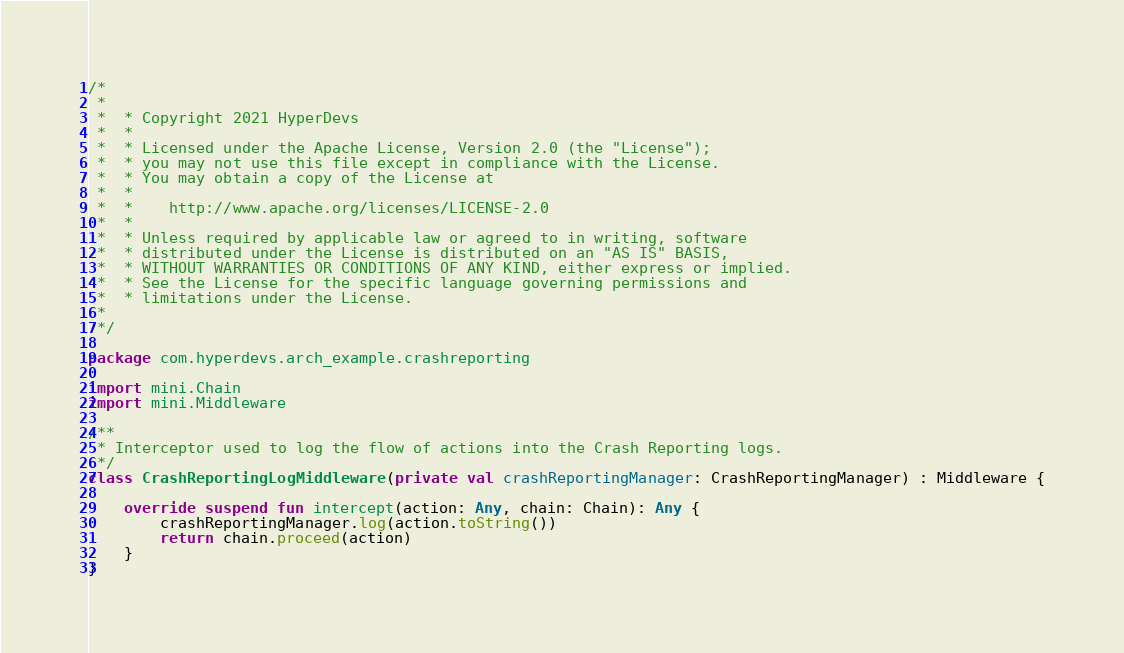<code> <loc_0><loc_0><loc_500><loc_500><_Kotlin_>/*
 *
 *  * Copyright 2021 HyperDevs
 *  *
 *  * Licensed under the Apache License, Version 2.0 (the "License");
 *  * you may not use this file except in compliance with the License.
 *  * You may obtain a copy of the License at
 *  *
 *  *    http://www.apache.org/licenses/LICENSE-2.0
 *  *
 *  * Unless required by applicable law or agreed to in writing, software
 *  * distributed under the License is distributed on an "AS IS" BASIS,
 *  * WITHOUT WARRANTIES OR CONDITIONS OF ANY KIND, either express or implied.
 *  * See the License for the specific language governing permissions and
 *  * limitations under the License.
 *
 */

package com.hyperdevs.arch_example.crashreporting

import mini.Chain
import mini.Middleware

/**
 * Interceptor used to log the flow of actions into the Crash Reporting logs.
 */
class CrashReportingLogMiddleware(private val crashReportingManager: CrashReportingManager) : Middleware {

    override suspend fun intercept(action: Any, chain: Chain): Any {
        crashReportingManager.log(action.toString())
        return chain.proceed(action)
    }
}</code> 